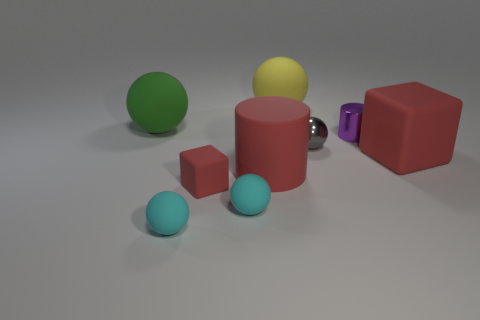Is the color of the large matte block the same as the block on the left side of the gray metallic object?
Offer a terse response. Yes. There is a small thing that is the same color as the large cube; what shape is it?
Your answer should be very brief. Cube. There is another rubber block that is the same color as the big cube; what is its size?
Keep it short and to the point. Small. How many other objects are there of the same size as the purple thing?
Offer a very short reply. 4. Are there an equal number of tiny matte blocks that are behind the big block and large yellow matte objects?
Provide a succinct answer. No. Is the color of the cube that is on the left side of the big yellow matte thing the same as the large rubber cube that is in front of the big yellow thing?
Your answer should be very brief. Yes. There is a sphere that is both behind the small rubber cube and in front of the big green rubber sphere; what is its material?
Make the answer very short. Metal. What color is the large rubber cube?
Offer a very short reply. Red. What number of other objects are the same shape as the tiny gray thing?
Provide a short and direct response. 4. Are there an equal number of large green rubber objects to the right of the small gray shiny object and rubber things that are behind the purple object?
Ensure brevity in your answer.  No. 